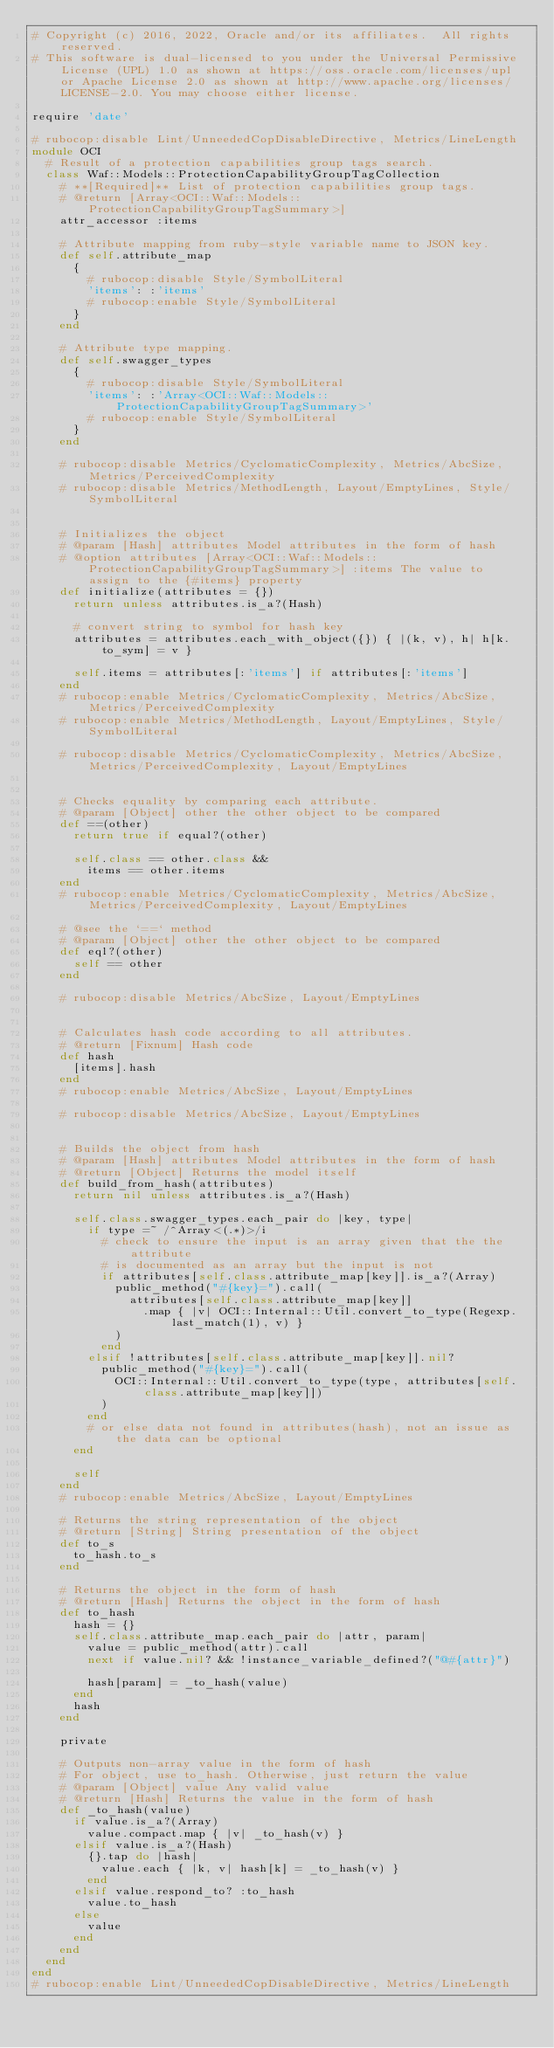Convert code to text. <code><loc_0><loc_0><loc_500><loc_500><_Ruby_># Copyright (c) 2016, 2022, Oracle and/or its affiliates.  All rights reserved.
# This software is dual-licensed to you under the Universal Permissive License (UPL) 1.0 as shown at https://oss.oracle.com/licenses/upl or Apache License 2.0 as shown at http://www.apache.org/licenses/LICENSE-2.0. You may choose either license.

require 'date'

# rubocop:disable Lint/UnneededCopDisableDirective, Metrics/LineLength
module OCI
  # Result of a protection capabilities group tags search.
  class Waf::Models::ProtectionCapabilityGroupTagCollection
    # **[Required]** List of protection capabilities group tags.
    # @return [Array<OCI::Waf::Models::ProtectionCapabilityGroupTagSummary>]
    attr_accessor :items

    # Attribute mapping from ruby-style variable name to JSON key.
    def self.attribute_map
      {
        # rubocop:disable Style/SymbolLiteral
        'items': :'items'
        # rubocop:enable Style/SymbolLiteral
      }
    end

    # Attribute type mapping.
    def self.swagger_types
      {
        # rubocop:disable Style/SymbolLiteral
        'items': :'Array<OCI::Waf::Models::ProtectionCapabilityGroupTagSummary>'
        # rubocop:enable Style/SymbolLiteral
      }
    end

    # rubocop:disable Metrics/CyclomaticComplexity, Metrics/AbcSize, Metrics/PerceivedComplexity
    # rubocop:disable Metrics/MethodLength, Layout/EmptyLines, Style/SymbolLiteral


    # Initializes the object
    # @param [Hash] attributes Model attributes in the form of hash
    # @option attributes [Array<OCI::Waf::Models::ProtectionCapabilityGroupTagSummary>] :items The value to assign to the {#items} property
    def initialize(attributes = {})
      return unless attributes.is_a?(Hash)

      # convert string to symbol for hash key
      attributes = attributes.each_with_object({}) { |(k, v), h| h[k.to_sym] = v }

      self.items = attributes[:'items'] if attributes[:'items']
    end
    # rubocop:enable Metrics/CyclomaticComplexity, Metrics/AbcSize, Metrics/PerceivedComplexity
    # rubocop:enable Metrics/MethodLength, Layout/EmptyLines, Style/SymbolLiteral

    # rubocop:disable Metrics/CyclomaticComplexity, Metrics/AbcSize, Metrics/PerceivedComplexity, Layout/EmptyLines


    # Checks equality by comparing each attribute.
    # @param [Object] other the other object to be compared
    def ==(other)
      return true if equal?(other)

      self.class == other.class &&
        items == other.items
    end
    # rubocop:enable Metrics/CyclomaticComplexity, Metrics/AbcSize, Metrics/PerceivedComplexity, Layout/EmptyLines

    # @see the `==` method
    # @param [Object] other the other object to be compared
    def eql?(other)
      self == other
    end

    # rubocop:disable Metrics/AbcSize, Layout/EmptyLines


    # Calculates hash code according to all attributes.
    # @return [Fixnum] Hash code
    def hash
      [items].hash
    end
    # rubocop:enable Metrics/AbcSize, Layout/EmptyLines

    # rubocop:disable Metrics/AbcSize, Layout/EmptyLines


    # Builds the object from hash
    # @param [Hash] attributes Model attributes in the form of hash
    # @return [Object] Returns the model itself
    def build_from_hash(attributes)
      return nil unless attributes.is_a?(Hash)

      self.class.swagger_types.each_pair do |key, type|
        if type =~ /^Array<(.*)>/i
          # check to ensure the input is an array given that the the attribute
          # is documented as an array but the input is not
          if attributes[self.class.attribute_map[key]].is_a?(Array)
            public_method("#{key}=").call(
              attributes[self.class.attribute_map[key]]
                .map { |v| OCI::Internal::Util.convert_to_type(Regexp.last_match(1), v) }
            )
          end
        elsif !attributes[self.class.attribute_map[key]].nil?
          public_method("#{key}=").call(
            OCI::Internal::Util.convert_to_type(type, attributes[self.class.attribute_map[key]])
          )
        end
        # or else data not found in attributes(hash), not an issue as the data can be optional
      end

      self
    end
    # rubocop:enable Metrics/AbcSize, Layout/EmptyLines

    # Returns the string representation of the object
    # @return [String] String presentation of the object
    def to_s
      to_hash.to_s
    end

    # Returns the object in the form of hash
    # @return [Hash] Returns the object in the form of hash
    def to_hash
      hash = {}
      self.class.attribute_map.each_pair do |attr, param|
        value = public_method(attr).call
        next if value.nil? && !instance_variable_defined?("@#{attr}")

        hash[param] = _to_hash(value)
      end
      hash
    end

    private

    # Outputs non-array value in the form of hash
    # For object, use to_hash. Otherwise, just return the value
    # @param [Object] value Any valid value
    # @return [Hash] Returns the value in the form of hash
    def _to_hash(value)
      if value.is_a?(Array)
        value.compact.map { |v| _to_hash(v) }
      elsif value.is_a?(Hash)
        {}.tap do |hash|
          value.each { |k, v| hash[k] = _to_hash(v) }
        end
      elsif value.respond_to? :to_hash
        value.to_hash
      else
        value
      end
    end
  end
end
# rubocop:enable Lint/UnneededCopDisableDirective, Metrics/LineLength
</code> 